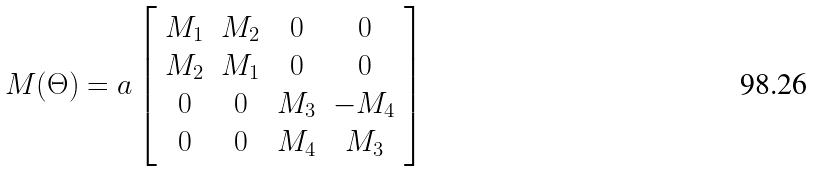<formula> <loc_0><loc_0><loc_500><loc_500>M ( \Theta ) = a \left [ \begin{array} { c c c c } M _ { 1 } & M _ { 2 } & 0 & 0 \\ M _ { 2 } & M _ { 1 } & 0 & 0 \\ 0 & 0 & M _ { 3 } & - M _ { 4 } \\ 0 & 0 & M _ { 4 } & M _ { 3 } \\ \end{array} \right ]</formula> 